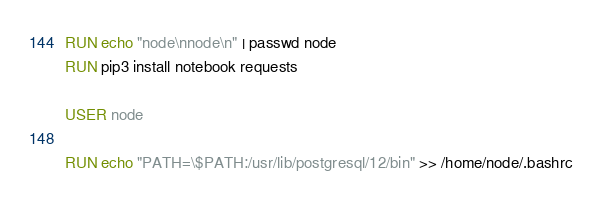<code> <loc_0><loc_0><loc_500><loc_500><_Dockerfile_>RUN echo "node\nnode\n" | passwd node 
RUN pip3 install notebook requests

USER node

RUN echo "PATH=\$PATH:/usr/lib/postgresql/12/bin" >> /home/node/.bashrc
</code> 